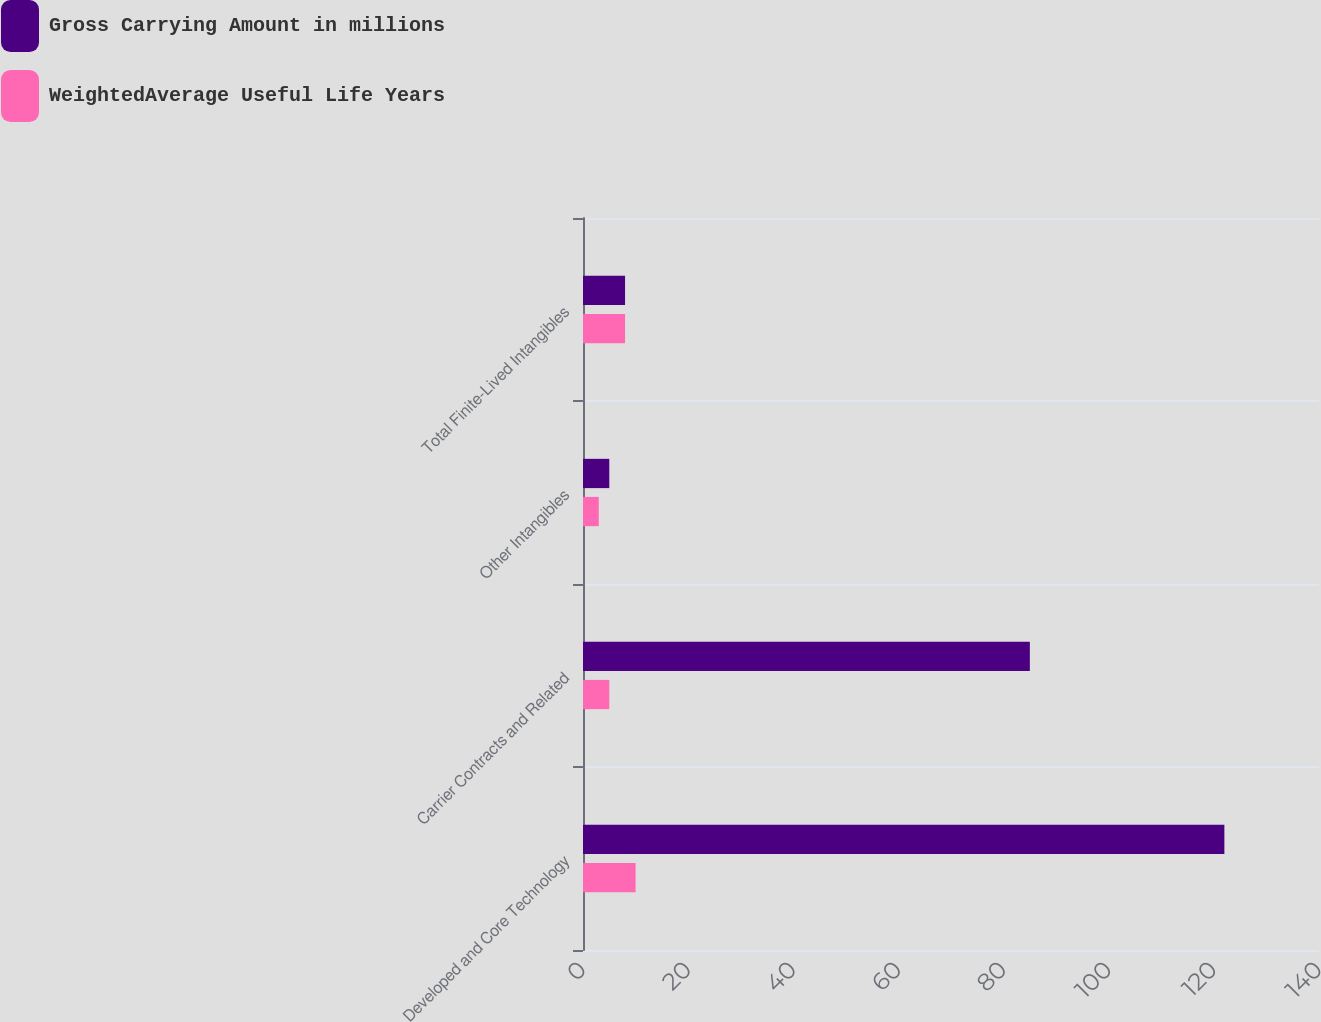Convert chart. <chart><loc_0><loc_0><loc_500><loc_500><stacked_bar_chart><ecel><fcel>Developed and Core Technology<fcel>Carrier Contracts and Related<fcel>Other Intangibles<fcel>Total Finite-Lived Intangibles<nl><fcel>Gross Carrying Amount in millions<fcel>122<fcel>85<fcel>5<fcel>8<nl><fcel>WeightedAverage Useful Life Years<fcel>10<fcel>5<fcel>3<fcel>8<nl></chart> 